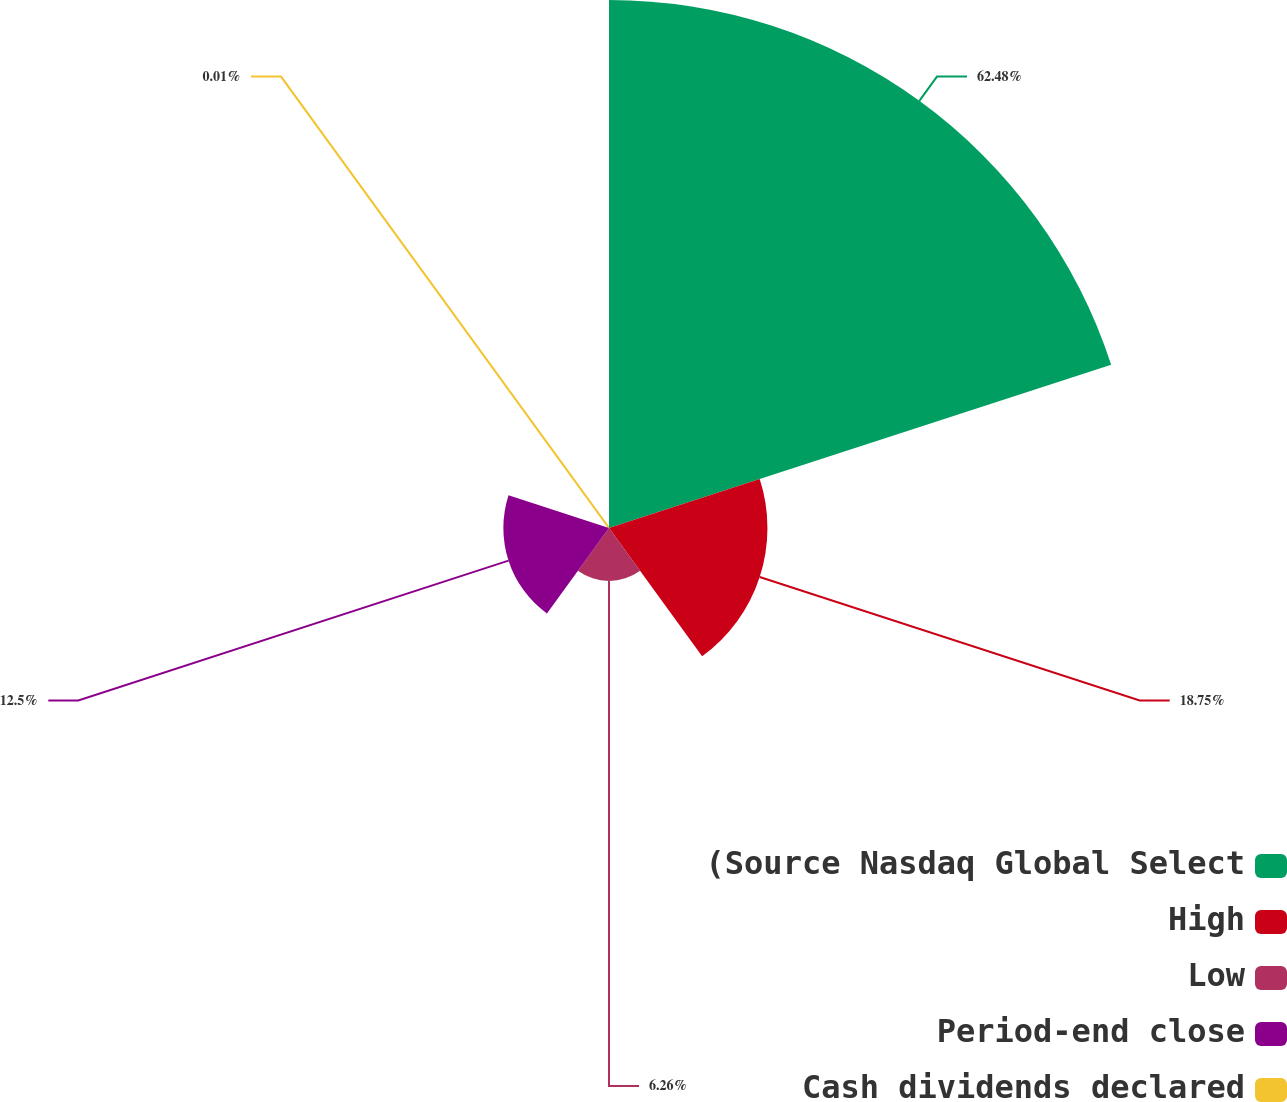Convert chart. <chart><loc_0><loc_0><loc_500><loc_500><pie_chart><fcel>(Source Nasdaq Global Select<fcel>High<fcel>Low<fcel>Period-end close<fcel>Cash dividends declared<nl><fcel>62.48%<fcel>18.75%<fcel>6.26%<fcel>12.5%<fcel>0.01%<nl></chart> 